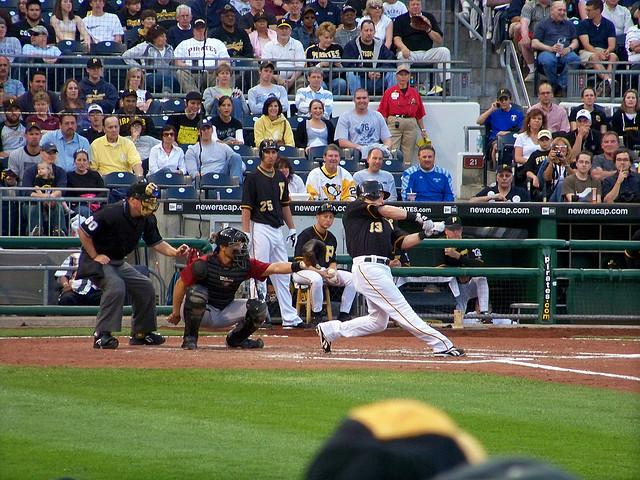Which former teammate of Chipper Jones is standing in the on-deck circle?

Choices:
A) otis nixon
B) david wright
C) adam laroche
D) mike trout adam laroche 